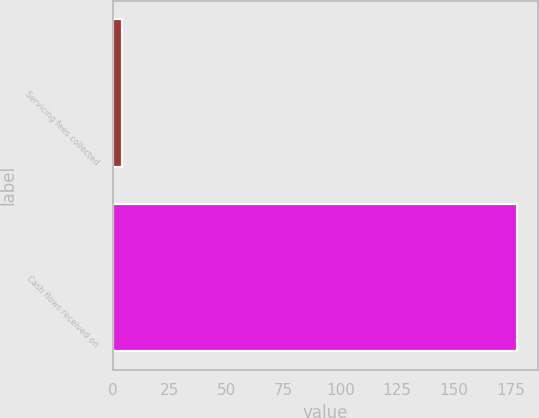<chart> <loc_0><loc_0><loc_500><loc_500><bar_chart><fcel>Servicing fees collected<fcel>Cash flows received on<nl><fcel>4<fcel>178<nl></chart> 